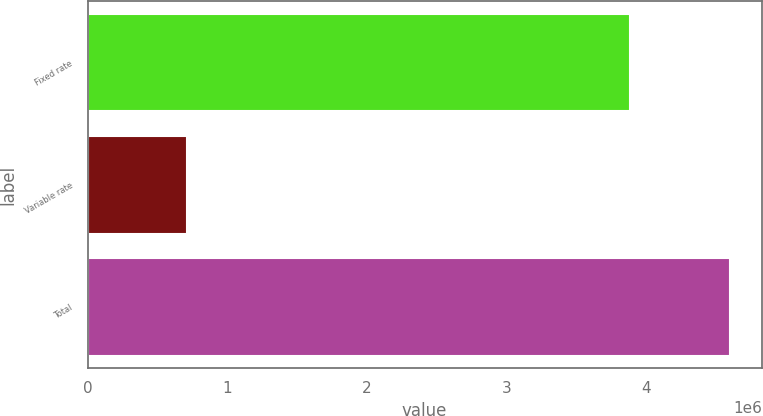<chart> <loc_0><loc_0><loc_500><loc_500><bar_chart><fcel>Fixed rate<fcel>Variable rate<fcel>Total<nl><fcel>3.88945e+06<fcel>711490<fcel>4.60094e+06<nl></chart> 